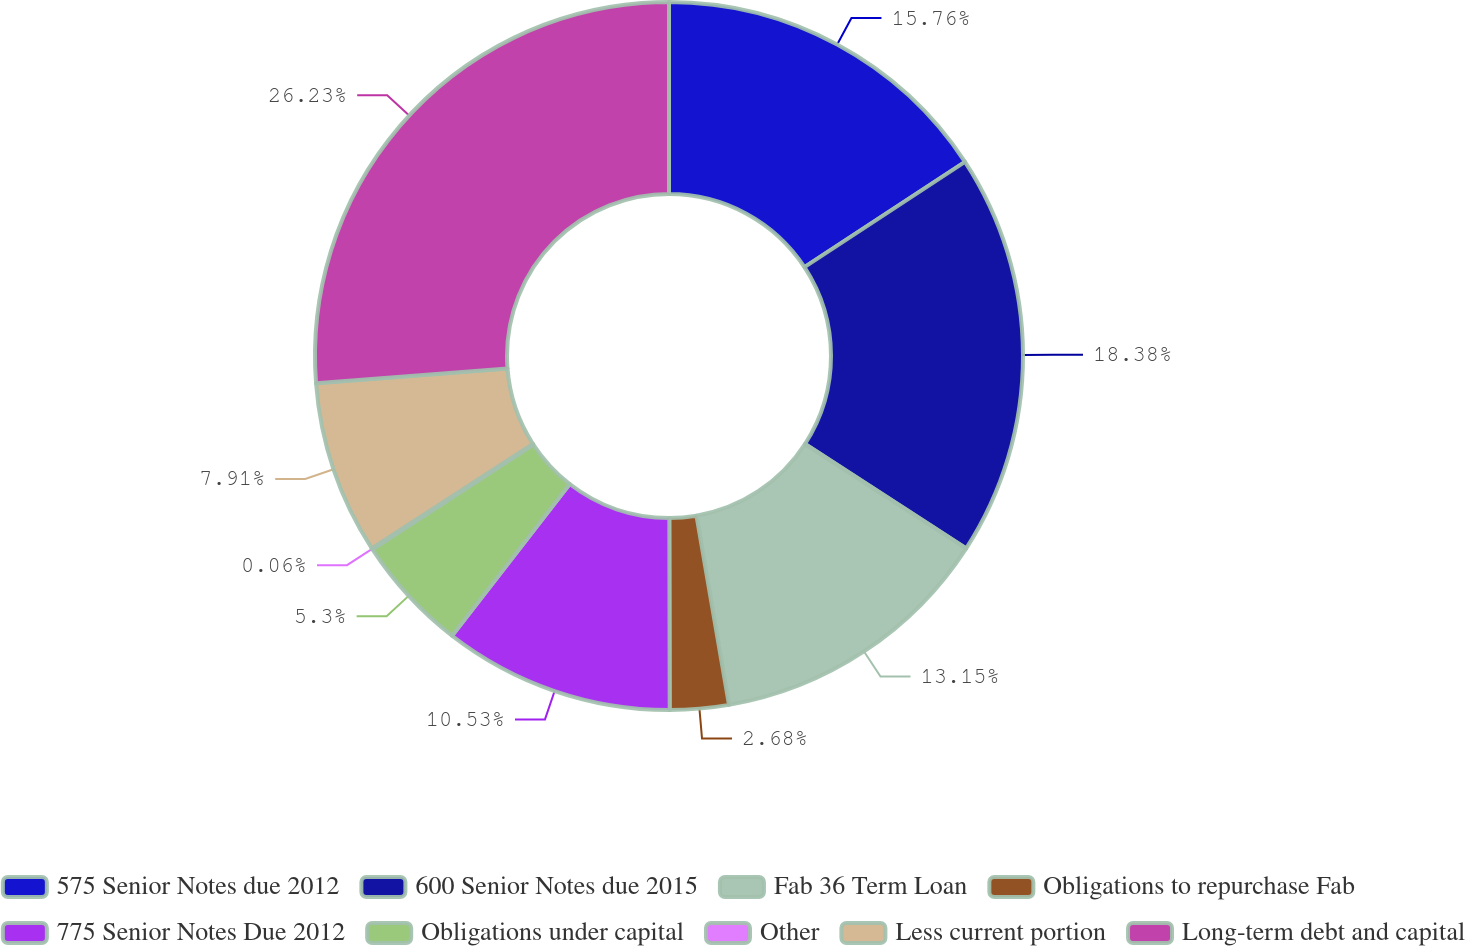Convert chart to OTSL. <chart><loc_0><loc_0><loc_500><loc_500><pie_chart><fcel>575 Senior Notes due 2012<fcel>600 Senior Notes due 2015<fcel>Fab 36 Term Loan<fcel>Obligations to repurchase Fab<fcel>775 Senior Notes Due 2012<fcel>Obligations under capital<fcel>Other<fcel>Less current portion<fcel>Long-term debt and capital<nl><fcel>15.76%<fcel>18.38%<fcel>13.15%<fcel>2.68%<fcel>10.53%<fcel>5.3%<fcel>0.06%<fcel>7.91%<fcel>26.23%<nl></chart> 